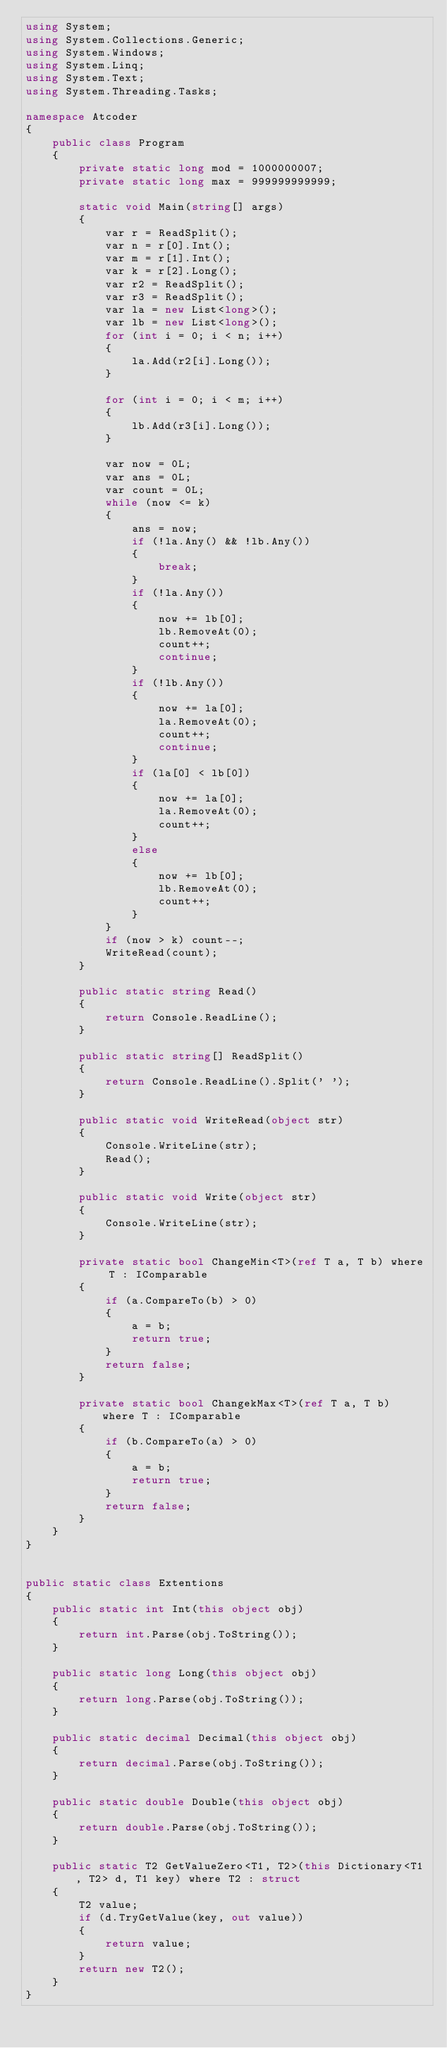<code> <loc_0><loc_0><loc_500><loc_500><_C#_>using System;
using System.Collections.Generic;
using System.Windows;
using System.Linq;
using System.Text;
using System.Threading.Tasks;

namespace Atcoder
{
    public class Program
    {
        private static long mod = 1000000007;
        private static long max = 999999999999;

        static void Main(string[] args)
        {
            var r = ReadSplit();
            var n = r[0].Int();
            var m = r[1].Int();
            var k = r[2].Long();
            var r2 = ReadSplit();
            var r3 = ReadSplit();
            var la = new List<long>();
            var lb = new List<long>();
            for (int i = 0; i < n; i++)
            {
                la.Add(r2[i].Long());
            }

            for (int i = 0; i < m; i++)
            {
                lb.Add(r3[i].Long());
            }

            var now = 0L;
            var ans = 0L;
            var count = 0L;
            while (now <= k)
            {
                ans = now;
                if (!la.Any() && !lb.Any())
                {
                    break;
                }
                if (!la.Any())
                {
                    now += lb[0];
                    lb.RemoveAt(0);
                    count++;
                    continue;
                }
                if (!lb.Any())
                {
                    now += la[0];
                    la.RemoveAt(0);
                    count++;
                    continue;
                }
                if (la[0] < lb[0])
                {
                    now += la[0];
                    la.RemoveAt(0);
                    count++;
                }
                else
                {
                    now += lb[0];
                    lb.RemoveAt(0);
                    count++;
                }
            }
            if (now > k) count--;
            WriteRead(count);
        }

        public static string Read()
        {
            return Console.ReadLine();
        }

        public static string[] ReadSplit()
        {
            return Console.ReadLine().Split(' ');
        }

        public static void WriteRead(object str)
        {
            Console.WriteLine(str);
            Read();
        }

        public static void Write(object str)
        {
            Console.WriteLine(str);
        }

        private static bool ChangeMin<T>(ref T a, T b) where T : IComparable
        {
            if (a.CompareTo(b) > 0)
            {
                a = b;
                return true;
            }
            return false;
        }

        private static bool ChangekMax<T>(ref T a, T b) where T : IComparable
        {
            if (b.CompareTo(a) > 0)
            {
                a = b;
                return true;
            }
            return false;
        }
    }
}


public static class Extentions
{
    public static int Int(this object obj)
    {
        return int.Parse(obj.ToString());
    }

    public static long Long(this object obj)
    {
        return long.Parse(obj.ToString());
    }

    public static decimal Decimal(this object obj)
    {
        return decimal.Parse(obj.ToString());
    }

    public static double Double(this object obj)
    {
        return double.Parse(obj.ToString());
    }

    public static T2 GetValueZero<T1, T2>(this Dictionary<T1, T2> d, T1 key) where T2 : struct
    {
        T2 value;
        if (d.TryGetValue(key, out value))
        {
            return value;
        }
        return new T2();
    }
}

</code> 